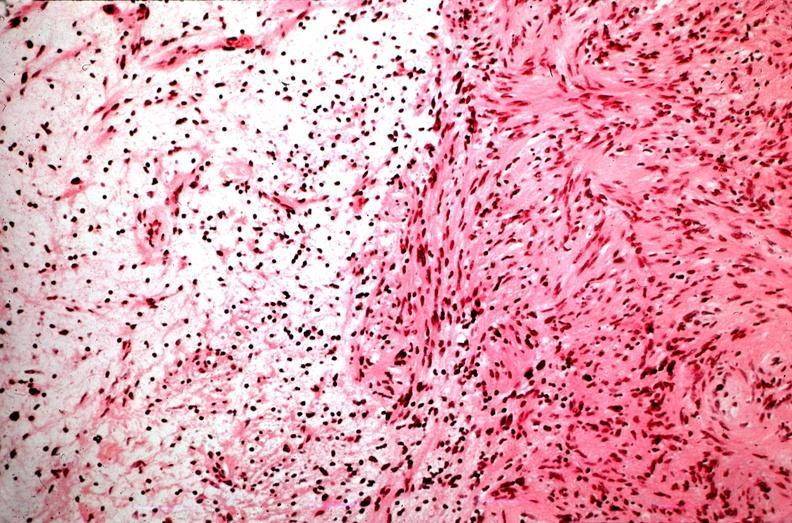what is present?
Answer the question using a single word or phrase. Nervous 